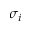Convert formula to latex. <formula><loc_0><loc_0><loc_500><loc_500>\sigma _ { i }</formula> 